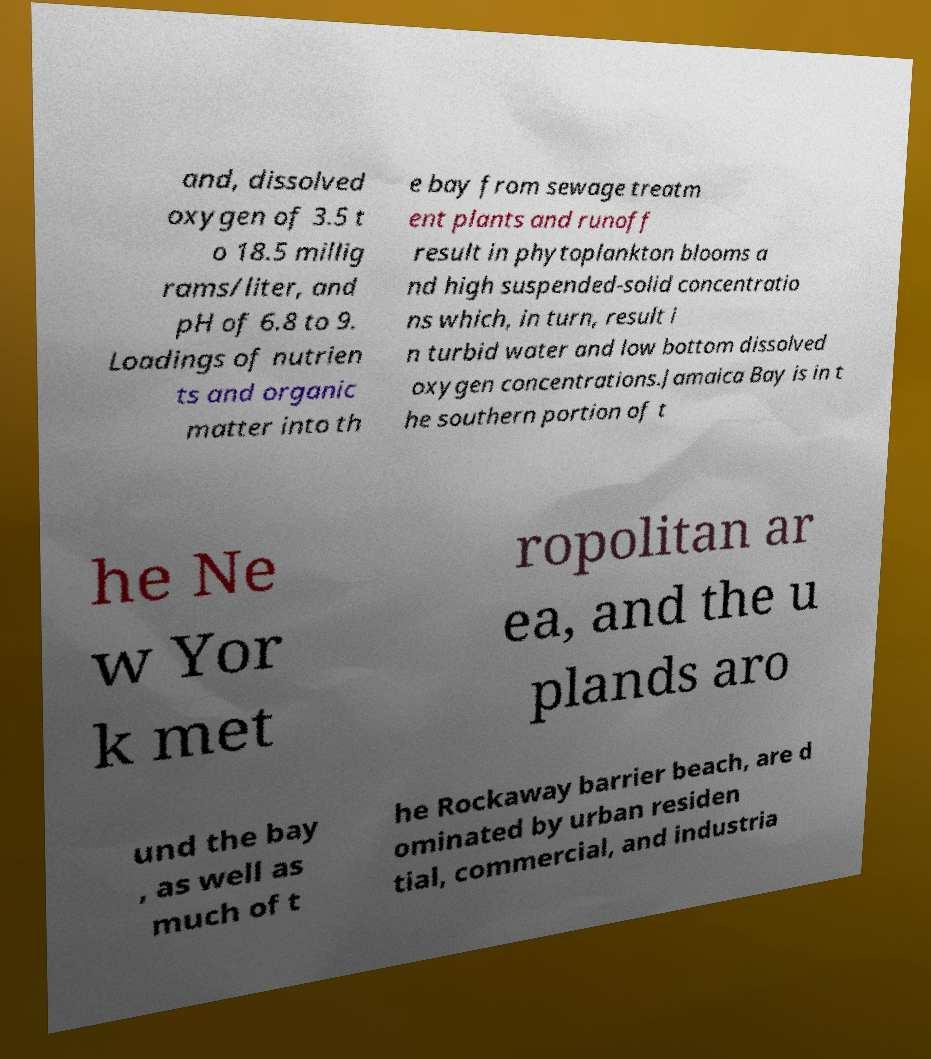Please read and relay the text visible in this image. What does it say? and, dissolved oxygen of 3.5 t o 18.5 millig rams/liter, and pH of 6.8 to 9. Loadings of nutrien ts and organic matter into th e bay from sewage treatm ent plants and runoff result in phytoplankton blooms a nd high suspended-solid concentratio ns which, in turn, result i n turbid water and low bottom dissolved oxygen concentrations.Jamaica Bay is in t he southern portion of t he Ne w Yor k met ropolitan ar ea, and the u plands aro und the bay , as well as much of t he Rockaway barrier beach, are d ominated by urban residen tial, commercial, and industria 